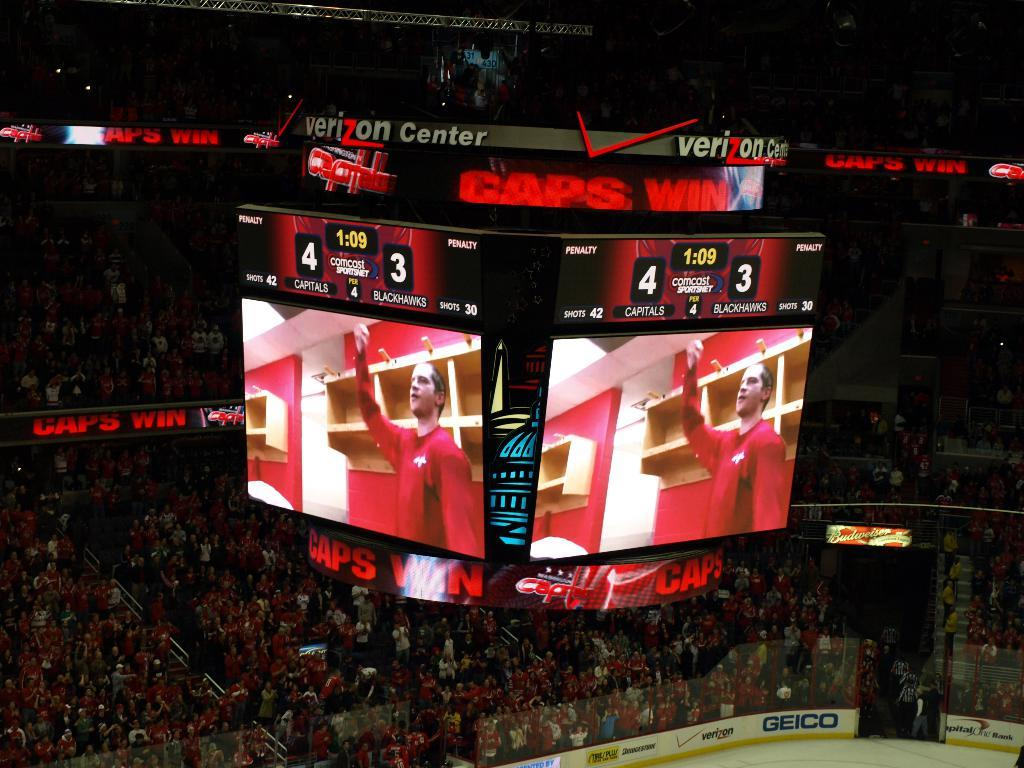<image>
Provide a brief description of the given image. An overhead scoreboard at the ice rink shows the Capitals outscoring the Blackhawks 4 to 3. 